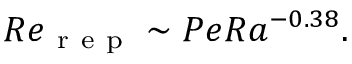<formula> <loc_0><loc_0><loc_500><loc_500>R e _ { r e p } \sim P e R a ^ { - 0 . 3 8 } .</formula> 